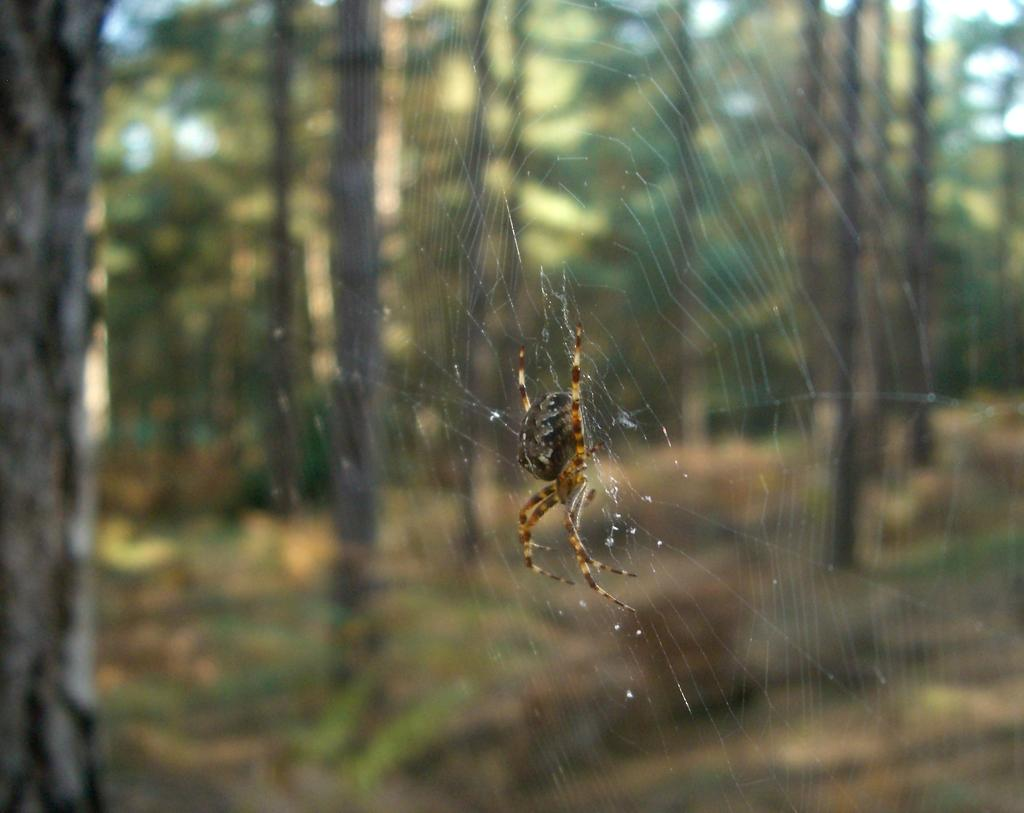What is the main subject of the image? There is a spider in the image. What is the spider doing in the image? The spider is building a spider web. What can be seen in the background of the image? There are trees in the background of the image. How would you describe the background of the image? The background of the image is blurred. Where is the seat located in the image? There is no seat present in the image. What type of party is being held in the image? There is no party depicted in the image; it features a spider building a spider web. 